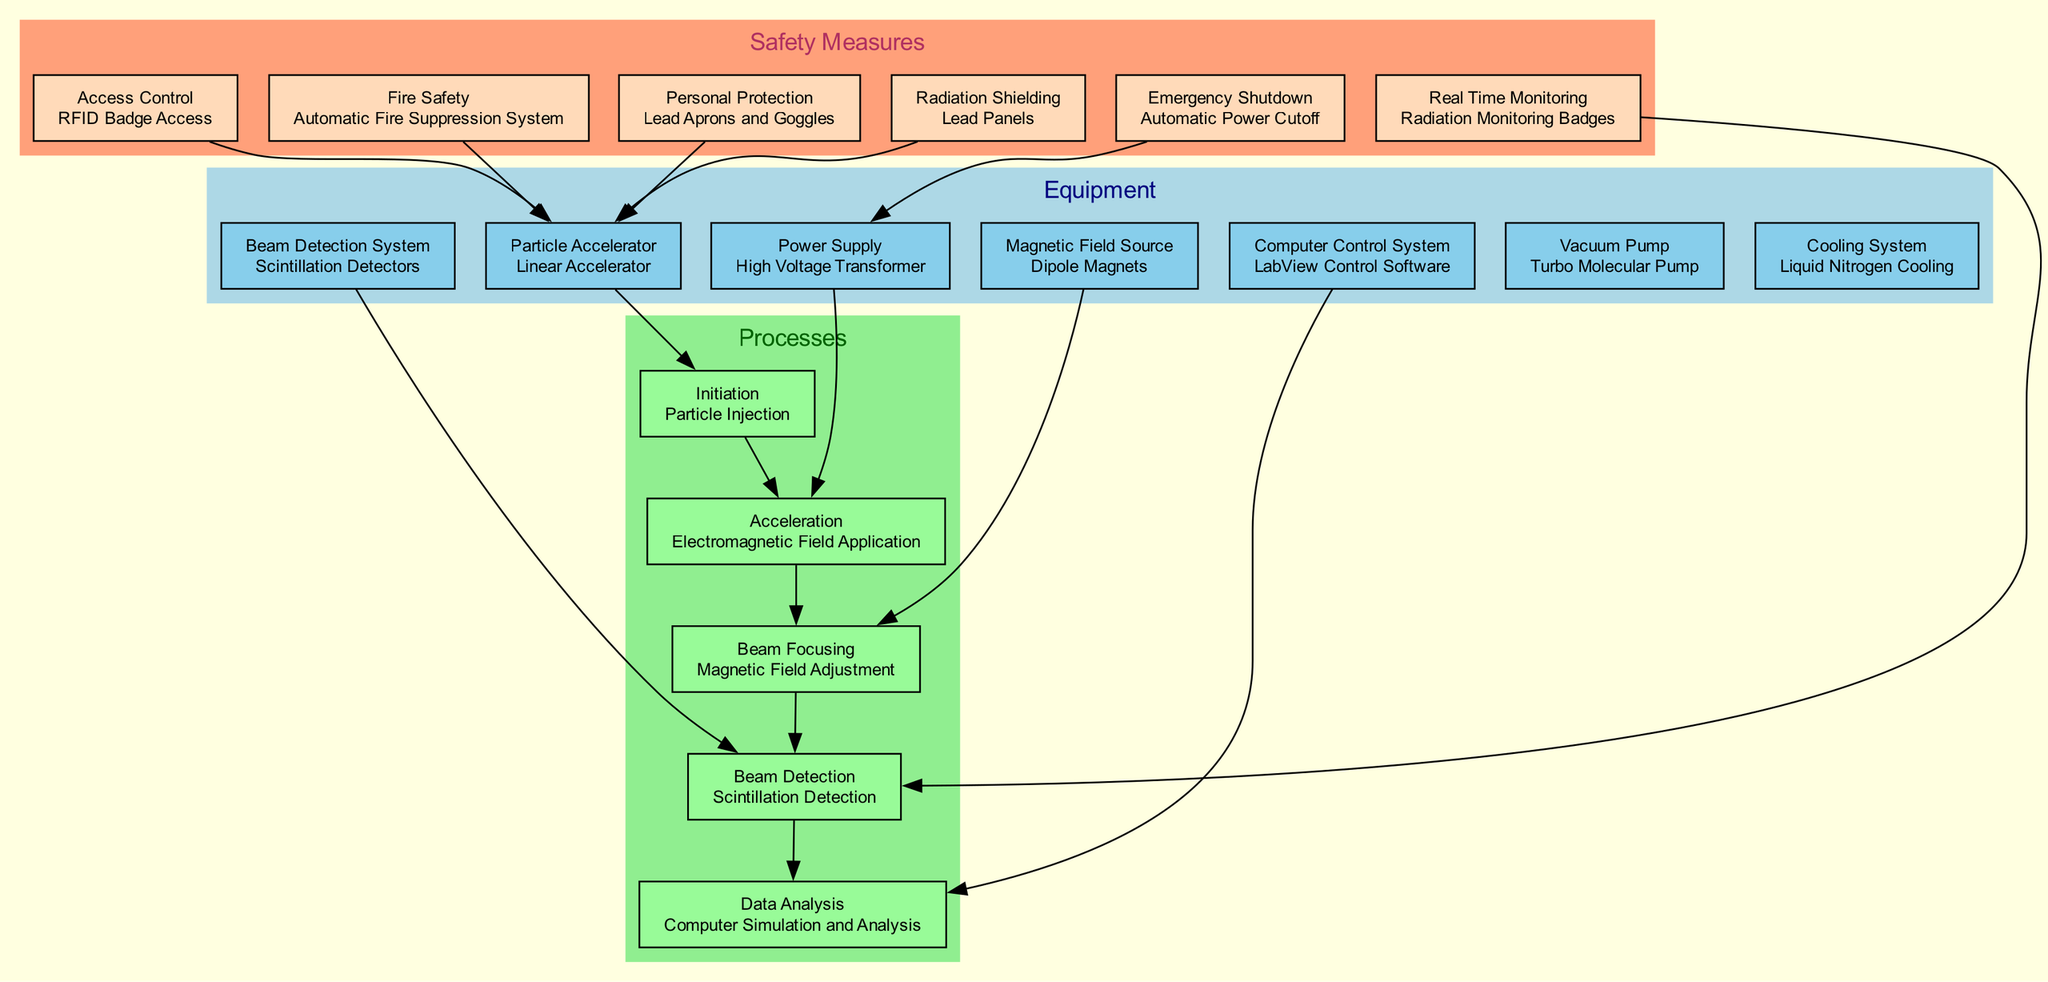What is the particle accelerator used in the experiment? The diagram states that the particle accelerator used is a Linear Accelerator, which is explicitly mentioned in the Equipment section.
Answer: Linear Accelerator How many safety measures are listed in the diagram? By counting the entries in the Safety Measures section of the diagram, there are a total of six safety measures highlighted.
Answer: 6 What type of cooling system is implemented in the experiment? The cooling system noted in the Equipment section is Liquid Nitrogen Cooling, which is directly mentioned and can be easily identified.
Answer: Liquid Nitrogen Cooling Which process directly follows the particle injection? The flow of processes shows that after Particle Injection, the next step is the Acceleration phase, which is indicated in the Processes section.
Answer: Acceleration What connects the Beam Detection System to Beam Detection? The edge between nodes indicates that the Beam Detection System supplies data or support to the Beam Detection process in the flow of the processes.
Answer: Beam Detection System How many equipment nodes are there in the diagram? The Equipment section lists six different pieces of equipment utilized in the particle acceleration experiment, which can be counted.
Answer: 6 Which safety measure is connected to the Power Supply? The Emergency Shutdown safety measure is linked to the Power Supply in the diagram, indicating that it affects or monitors this piece of equipment.
Answer: Emergency Shutdown What process involves Magnetic Field Adjustment? According to the Processes section, Beam Focusing involves Magnetic Field Adjustment, connecting the electromagnetic processes to beam manipulation.
Answer: Beam Focusing What source provides the magnetic field for the beam? The diagram clearly states that Dipole Magnets are the source of the magnetic field used for beam focusing in the Equipment section.
Answer: Dipole Magnets 